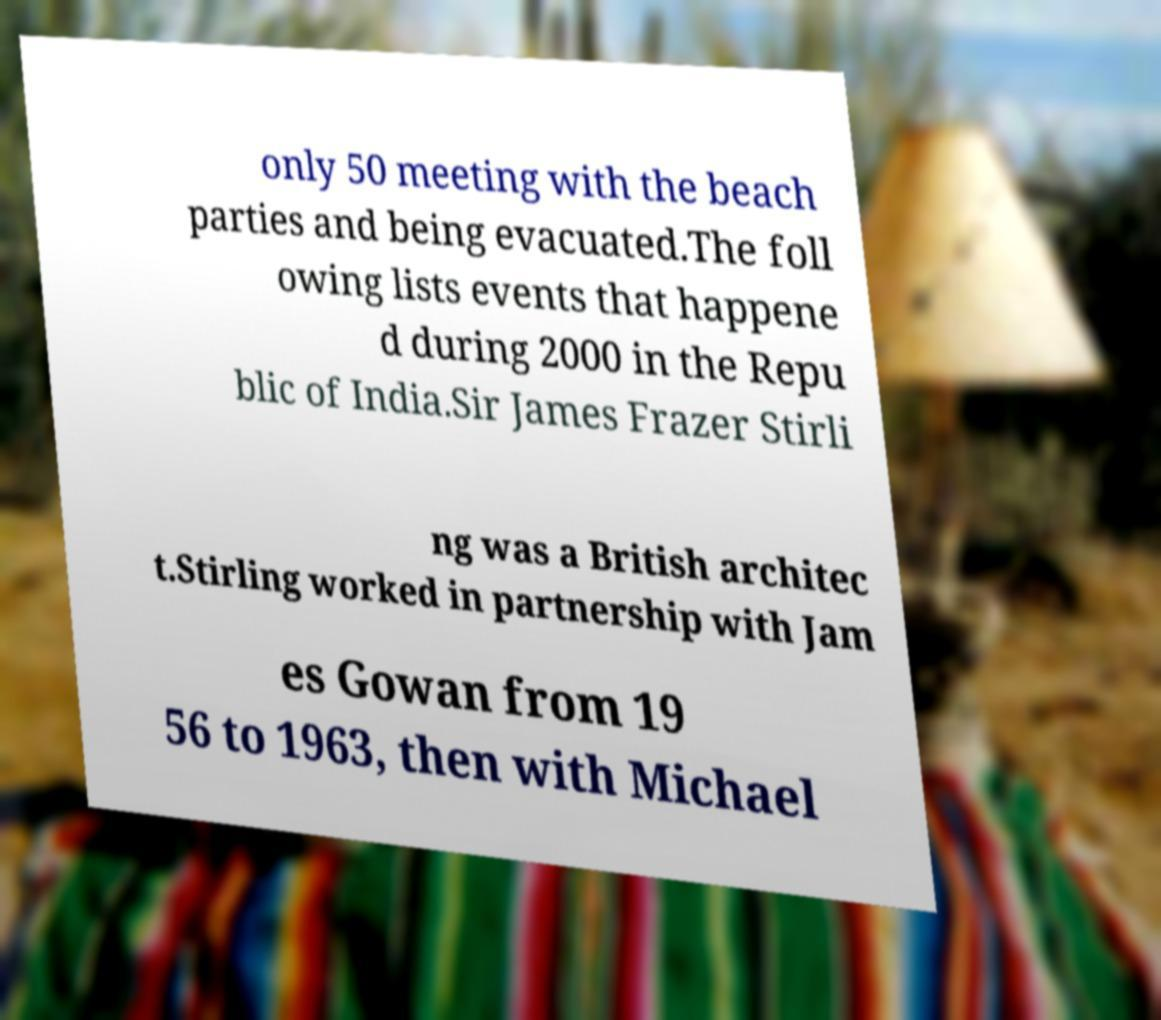There's text embedded in this image that I need extracted. Can you transcribe it verbatim? only 50 meeting with the beach parties and being evacuated.The foll owing lists events that happene d during 2000 in the Repu blic of India.Sir James Frazer Stirli ng was a British architec t.Stirling worked in partnership with Jam es Gowan from 19 56 to 1963, then with Michael 